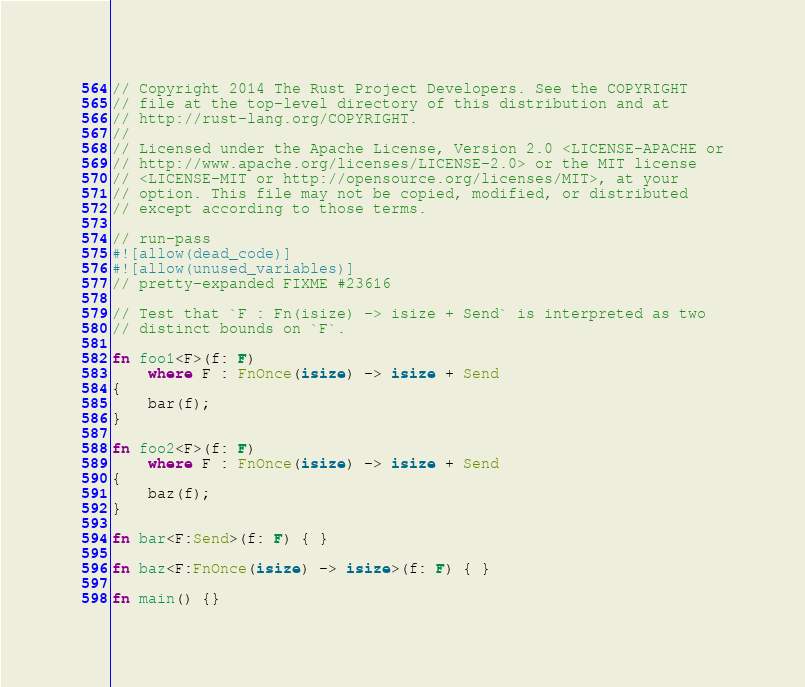<code> <loc_0><loc_0><loc_500><loc_500><_Rust_>// Copyright 2014 The Rust Project Developers. See the COPYRIGHT
// file at the top-level directory of this distribution and at
// http://rust-lang.org/COPYRIGHT.
//
// Licensed under the Apache License, Version 2.0 <LICENSE-APACHE or
// http://www.apache.org/licenses/LICENSE-2.0> or the MIT license
// <LICENSE-MIT or http://opensource.org/licenses/MIT>, at your
// option. This file may not be copied, modified, or distributed
// except according to those terms.

// run-pass
#![allow(dead_code)]
#![allow(unused_variables)]
// pretty-expanded FIXME #23616

// Test that `F : Fn(isize) -> isize + Send` is interpreted as two
// distinct bounds on `F`.

fn foo1<F>(f: F)
    where F : FnOnce(isize) -> isize + Send
{
    bar(f);
}

fn foo2<F>(f: F)
    where F : FnOnce(isize) -> isize + Send
{
    baz(f);
}

fn bar<F:Send>(f: F) { }

fn baz<F:FnOnce(isize) -> isize>(f: F) { }

fn main() {}
</code> 